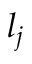<formula> <loc_0><loc_0><loc_500><loc_500>l _ { j }</formula> 